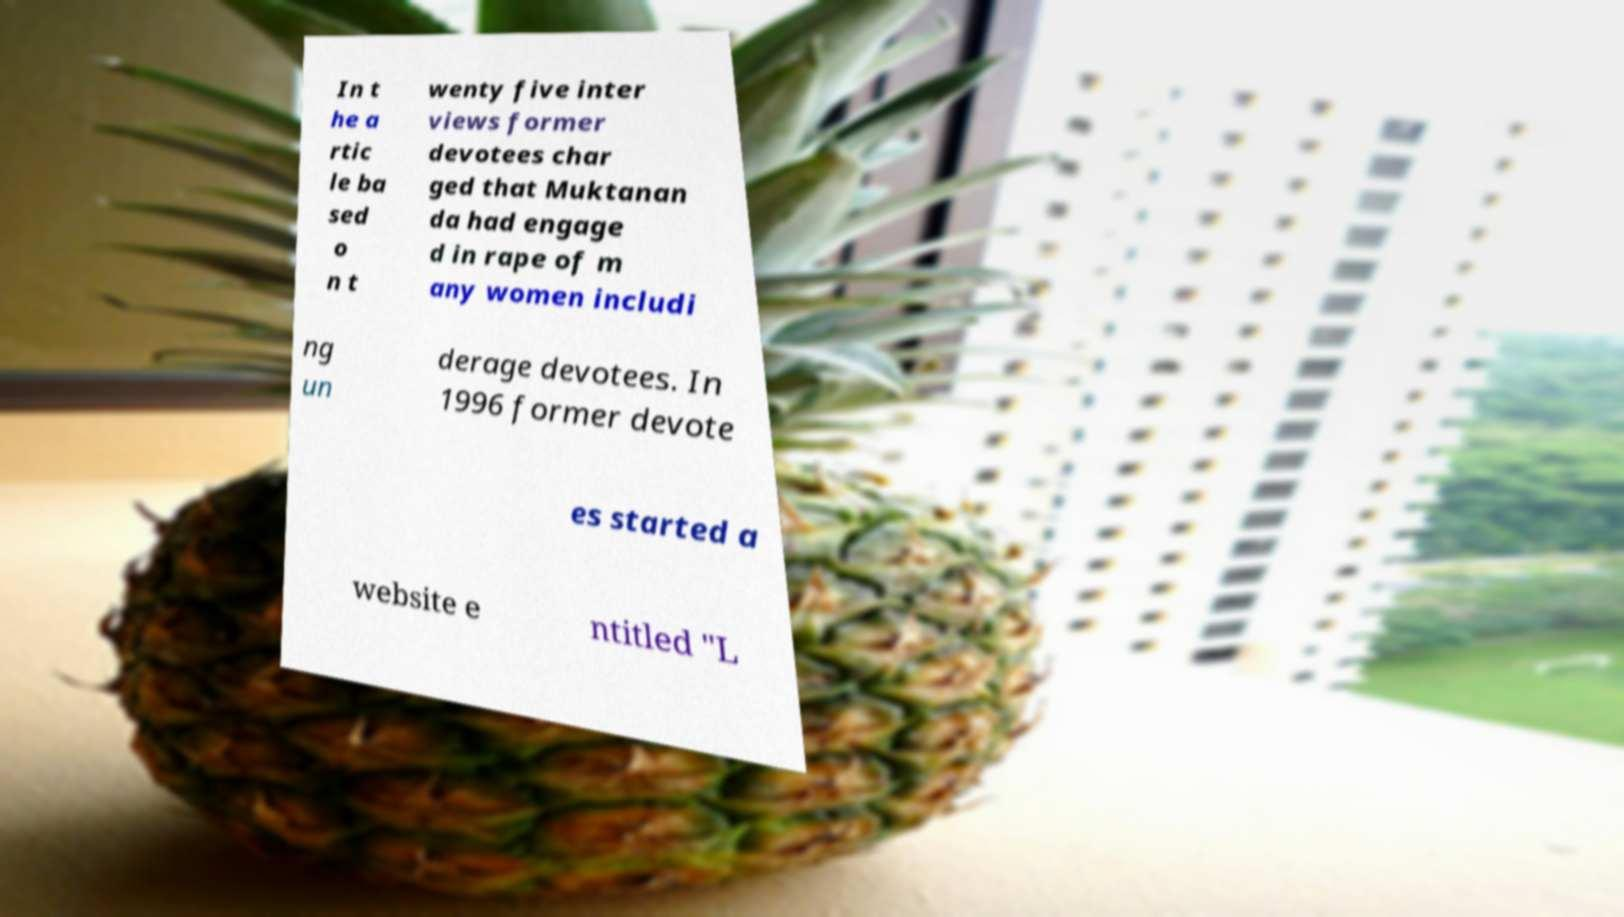Could you extract and type out the text from this image? In t he a rtic le ba sed o n t wenty five inter views former devotees char ged that Muktanan da had engage d in rape of m any women includi ng un derage devotees. In 1996 former devote es started a website e ntitled "L 